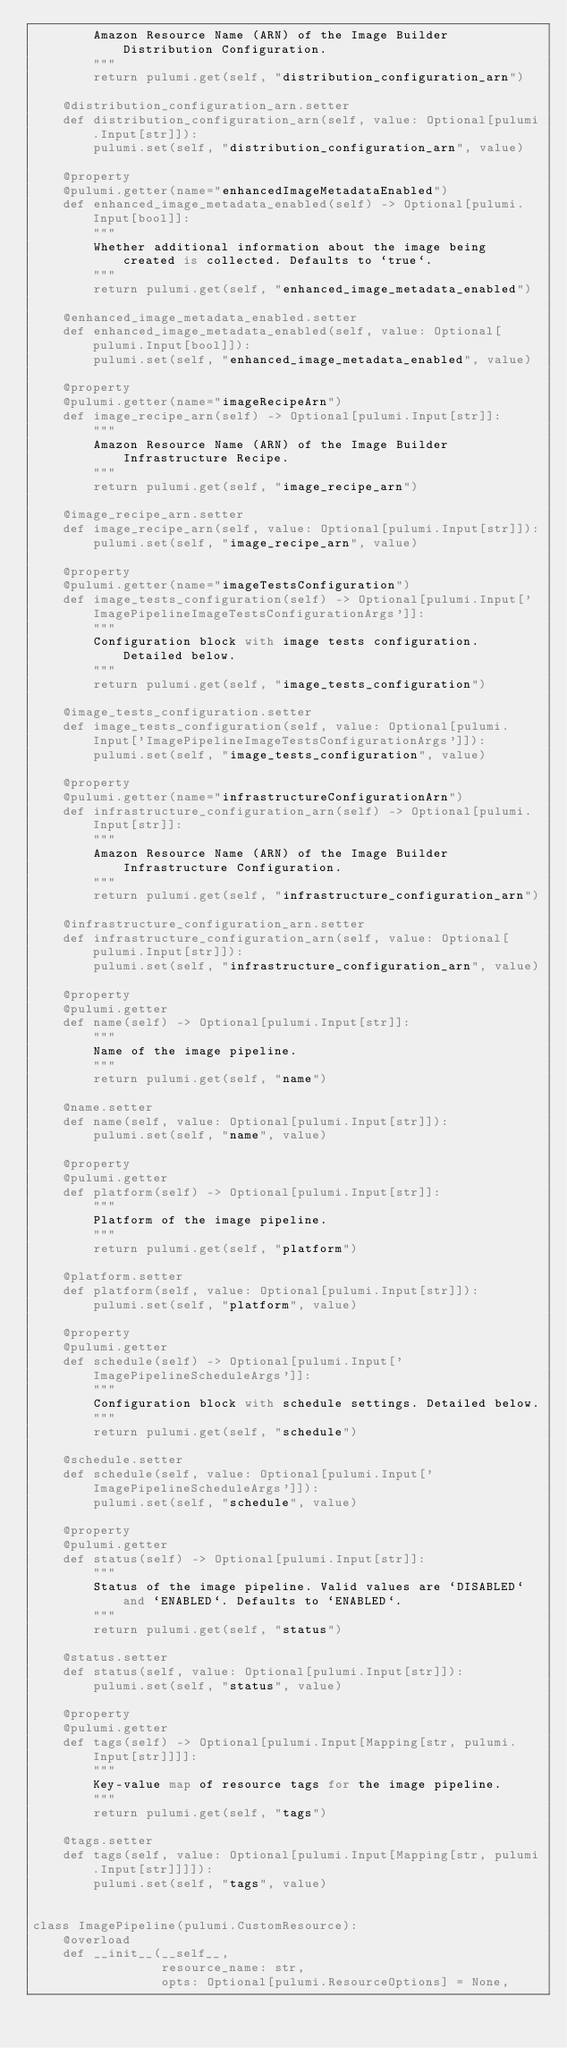<code> <loc_0><loc_0><loc_500><loc_500><_Python_>        Amazon Resource Name (ARN) of the Image Builder Distribution Configuration.
        """
        return pulumi.get(self, "distribution_configuration_arn")

    @distribution_configuration_arn.setter
    def distribution_configuration_arn(self, value: Optional[pulumi.Input[str]]):
        pulumi.set(self, "distribution_configuration_arn", value)

    @property
    @pulumi.getter(name="enhancedImageMetadataEnabled")
    def enhanced_image_metadata_enabled(self) -> Optional[pulumi.Input[bool]]:
        """
        Whether additional information about the image being created is collected. Defaults to `true`.
        """
        return pulumi.get(self, "enhanced_image_metadata_enabled")

    @enhanced_image_metadata_enabled.setter
    def enhanced_image_metadata_enabled(self, value: Optional[pulumi.Input[bool]]):
        pulumi.set(self, "enhanced_image_metadata_enabled", value)

    @property
    @pulumi.getter(name="imageRecipeArn")
    def image_recipe_arn(self) -> Optional[pulumi.Input[str]]:
        """
        Amazon Resource Name (ARN) of the Image Builder Infrastructure Recipe.
        """
        return pulumi.get(self, "image_recipe_arn")

    @image_recipe_arn.setter
    def image_recipe_arn(self, value: Optional[pulumi.Input[str]]):
        pulumi.set(self, "image_recipe_arn", value)

    @property
    @pulumi.getter(name="imageTestsConfiguration")
    def image_tests_configuration(self) -> Optional[pulumi.Input['ImagePipelineImageTestsConfigurationArgs']]:
        """
        Configuration block with image tests configuration. Detailed below.
        """
        return pulumi.get(self, "image_tests_configuration")

    @image_tests_configuration.setter
    def image_tests_configuration(self, value: Optional[pulumi.Input['ImagePipelineImageTestsConfigurationArgs']]):
        pulumi.set(self, "image_tests_configuration", value)

    @property
    @pulumi.getter(name="infrastructureConfigurationArn")
    def infrastructure_configuration_arn(self) -> Optional[pulumi.Input[str]]:
        """
        Amazon Resource Name (ARN) of the Image Builder Infrastructure Configuration.
        """
        return pulumi.get(self, "infrastructure_configuration_arn")

    @infrastructure_configuration_arn.setter
    def infrastructure_configuration_arn(self, value: Optional[pulumi.Input[str]]):
        pulumi.set(self, "infrastructure_configuration_arn", value)

    @property
    @pulumi.getter
    def name(self) -> Optional[pulumi.Input[str]]:
        """
        Name of the image pipeline.
        """
        return pulumi.get(self, "name")

    @name.setter
    def name(self, value: Optional[pulumi.Input[str]]):
        pulumi.set(self, "name", value)

    @property
    @pulumi.getter
    def platform(self) -> Optional[pulumi.Input[str]]:
        """
        Platform of the image pipeline.
        """
        return pulumi.get(self, "platform")

    @platform.setter
    def platform(self, value: Optional[pulumi.Input[str]]):
        pulumi.set(self, "platform", value)

    @property
    @pulumi.getter
    def schedule(self) -> Optional[pulumi.Input['ImagePipelineScheduleArgs']]:
        """
        Configuration block with schedule settings. Detailed below.
        """
        return pulumi.get(self, "schedule")

    @schedule.setter
    def schedule(self, value: Optional[pulumi.Input['ImagePipelineScheduleArgs']]):
        pulumi.set(self, "schedule", value)

    @property
    @pulumi.getter
    def status(self) -> Optional[pulumi.Input[str]]:
        """
        Status of the image pipeline. Valid values are `DISABLED` and `ENABLED`. Defaults to `ENABLED`.
        """
        return pulumi.get(self, "status")

    @status.setter
    def status(self, value: Optional[pulumi.Input[str]]):
        pulumi.set(self, "status", value)

    @property
    @pulumi.getter
    def tags(self) -> Optional[pulumi.Input[Mapping[str, pulumi.Input[str]]]]:
        """
        Key-value map of resource tags for the image pipeline.
        """
        return pulumi.get(self, "tags")

    @tags.setter
    def tags(self, value: Optional[pulumi.Input[Mapping[str, pulumi.Input[str]]]]):
        pulumi.set(self, "tags", value)


class ImagePipeline(pulumi.CustomResource):
    @overload
    def __init__(__self__,
                 resource_name: str,
                 opts: Optional[pulumi.ResourceOptions] = None,</code> 